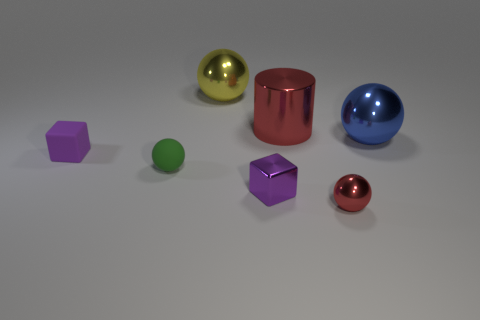Add 3 big yellow metallic balls. How many objects exist? 10 Subtract all balls. How many objects are left? 3 Subtract all tiny blue shiny cubes. Subtract all yellow shiny spheres. How many objects are left? 6 Add 5 big cylinders. How many big cylinders are left? 6 Add 4 large cylinders. How many large cylinders exist? 5 Subtract 1 red cylinders. How many objects are left? 6 